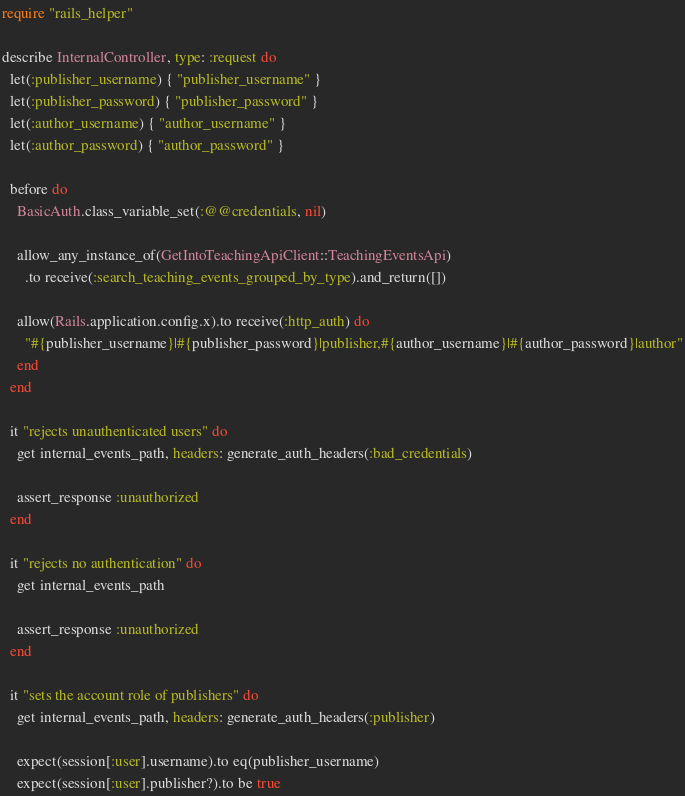<code> <loc_0><loc_0><loc_500><loc_500><_Ruby_>require "rails_helper"

describe InternalController, type: :request do
  let(:publisher_username) { "publisher_username" }
  let(:publisher_password) { "publisher_password" }
  let(:author_username) { "author_username" }
  let(:author_password) { "author_password" }

  before do
    BasicAuth.class_variable_set(:@@credentials, nil)

    allow_any_instance_of(GetIntoTeachingApiClient::TeachingEventsApi)
      .to receive(:search_teaching_events_grouped_by_type).and_return([])

    allow(Rails.application.config.x).to receive(:http_auth) do
      "#{publisher_username}|#{publisher_password}|publisher,#{author_username}|#{author_password}|author"
    end
  end

  it "rejects unauthenticated users" do
    get internal_events_path, headers: generate_auth_headers(:bad_credentials)

    assert_response :unauthorized
  end

  it "rejects no authentication" do
    get internal_events_path

    assert_response :unauthorized
  end

  it "sets the account role of publishers" do
    get internal_events_path, headers: generate_auth_headers(:publisher)

    expect(session[:user].username).to eq(publisher_username)
    expect(session[:user].publisher?).to be true</code> 